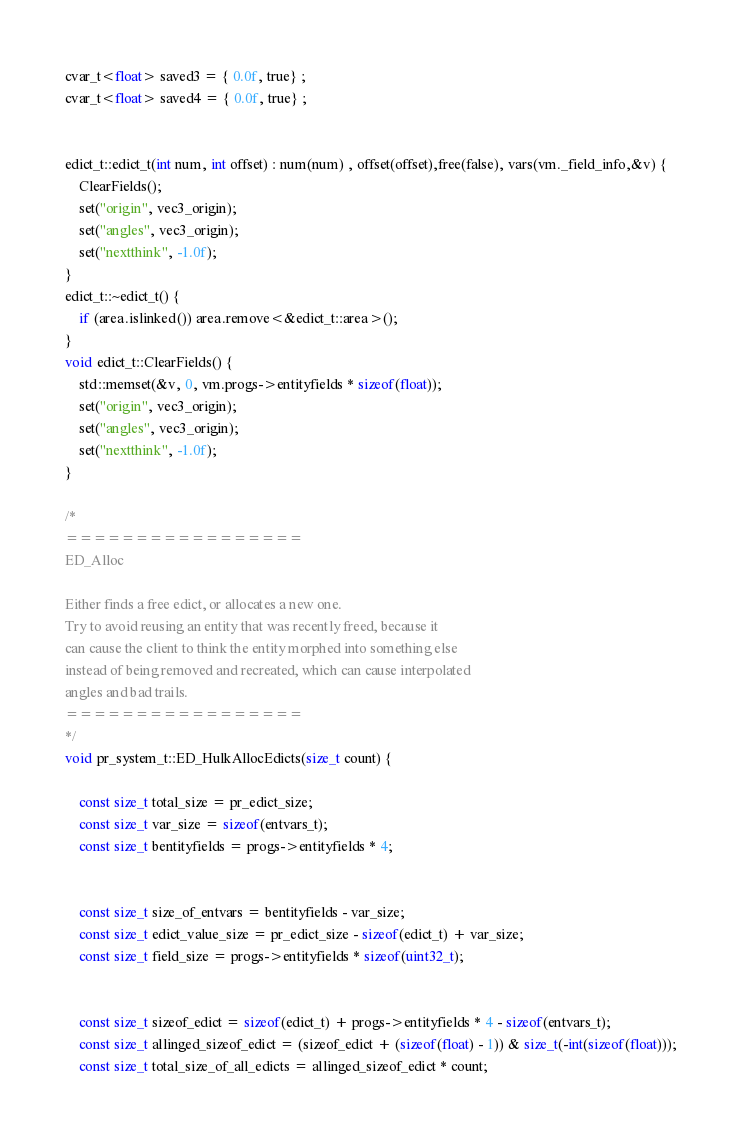<code> <loc_0><loc_0><loc_500><loc_500><_C++_>cvar_t<float> saved3 = { 0.0f, true} ;
cvar_t<float> saved4 = { 0.0f, true} ;


edict_t::edict_t(int num, int offset) : num(num) , offset(offset),free(false), vars(vm._field_info,&v) {
	ClearFields();
	set("origin", vec3_origin);
	set("angles", vec3_origin);
	set("nextthink", -1.0f);
}
edict_t::~edict_t() {
	if (area.islinked()) area.remove<&edict_t::area>();
}
void edict_t::ClearFields() {
	std::memset(&v, 0, vm.progs->entityfields * sizeof(float));
	set("origin", vec3_origin);
	set("angles", vec3_origin);
	set("nextthink", -1.0f);
}

/*
=================
ED_Alloc

Either finds a free edict, or allocates a new one.
Try to avoid reusing an entity that was recently freed, because it
can cause the client to think the entity morphed into something else
instead of being removed and recreated, which can cause interpolated
angles and bad trails.
=================
*/
void pr_system_t::ED_HulkAllocEdicts(size_t count) {

	const size_t total_size = pr_edict_size;
	const size_t var_size = sizeof(entvars_t);
	const size_t bentityfields = progs->entityfields * 4;


	const size_t size_of_entvars = bentityfields - var_size;
	const size_t edict_value_size = pr_edict_size - sizeof(edict_t) + var_size;
	const size_t field_size = progs->entityfields * sizeof(uint32_t);


	const size_t sizeof_edict = sizeof(edict_t) + progs->entityfields * 4 - sizeof(entvars_t);
	const size_t allinged_sizeof_edict = (sizeof_edict + (sizeof(float) - 1)) & size_t(-int(sizeof(float)));
	const size_t total_size_of_all_edicts = allinged_sizeof_edict * count;
</code> 